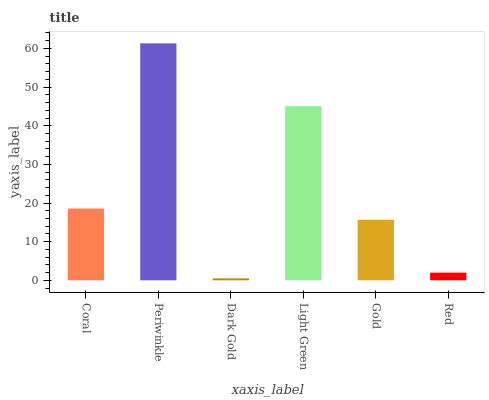Is Periwinkle the minimum?
Answer yes or no. No. Is Dark Gold the maximum?
Answer yes or no. No. Is Periwinkle greater than Dark Gold?
Answer yes or no. Yes. Is Dark Gold less than Periwinkle?
Answer yes or no. Yes. Is Dark Gold greater than Periwinkle?
Answer yes or no. No. Is Periwinkle less than Dark Gold?
Answer yes or no. No. Is Coral the high median?
Answer yes or no. Yes. Is Gold the low median?
Answer yes or no. Yes. Is Dark Gold the high median?
Answer yes or no. No. Is Light Green the low median?
Answer yes or no. No. 